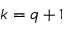Convert formula to latex. <formula><loc_0><loc_0><loc_500><loc_500>k = q + 1</formula> 